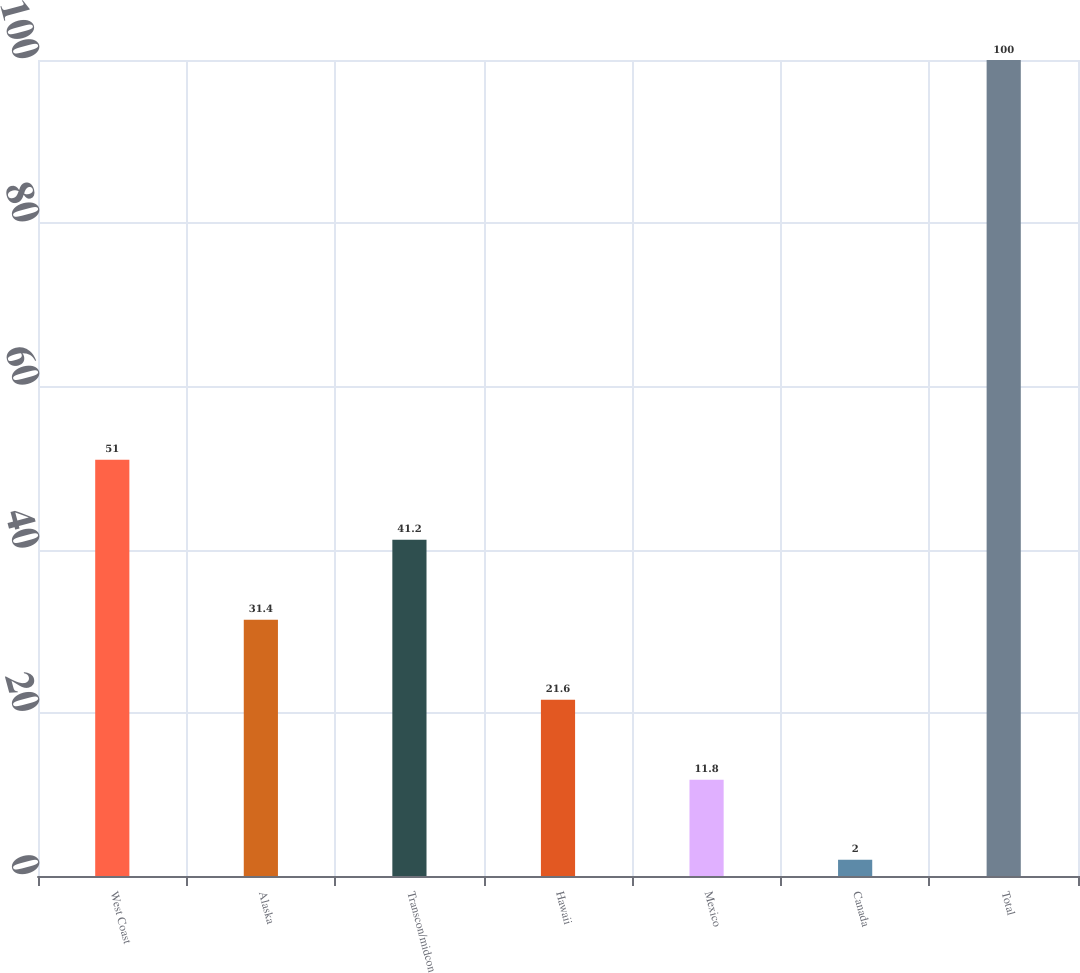Convert chart. <chart><loc_0><loc_0><loc_500><loc_500><bar_chart><fcel>West Coast<fcel>Alaska<fcel>Transcon/midcon<fcel>Hawaii<fcel>Mexico<fcel>Canada<fcel>Total<nl><fcel>51<fcel>31.4<fcel>41.2<fcel>21.6<fcel>11.8<fcel>2<fcel>100<nl></chart> 